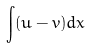Convert formula to latex. <formula><loc_0><loc_0><loc_500><loc_500>\int ( u - v ) d x</formula> 